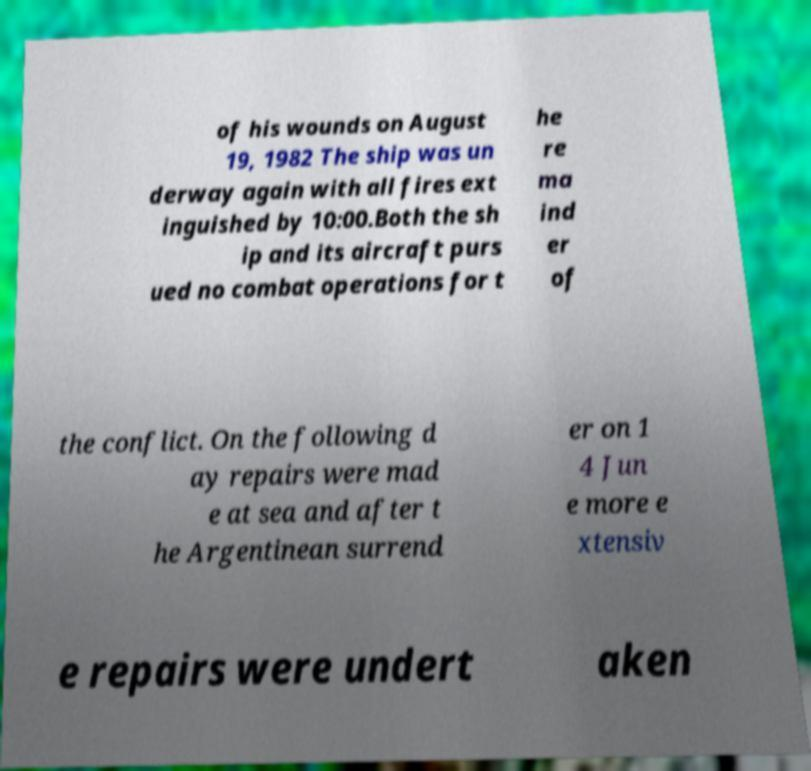I need the written content from this picture converted into text. Can you do that? of his wounds on August 19, 1982 The ship was un derway again with all fires ext inguished by 10:00.Both the sh ip and its aircraft purs ued no combat operations for t he re ma ind er of the conflict. On the following d ay repairs were mad e at sea and after t he Argentinean surrend er on 1 4 Jun e more e xtensiv e repairs were undert aken 